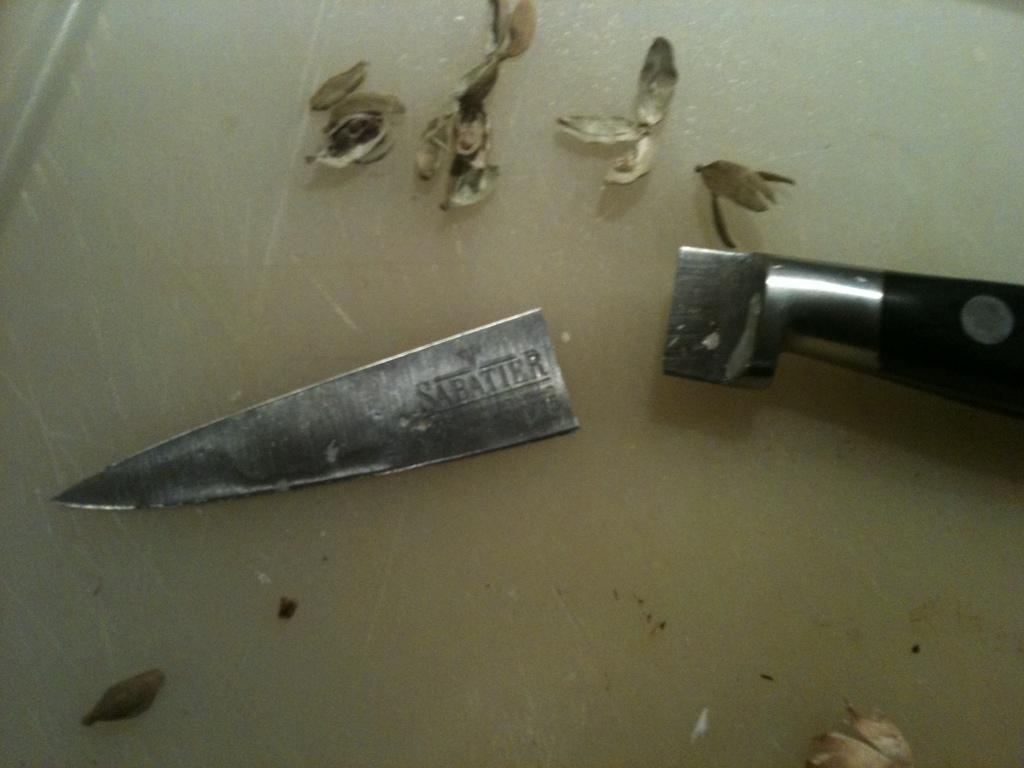What object appears to be damaged in the image? There is a broken knife in the image. What type of spice can be seen in the image? There are cardamoms in the image. Where is the basketball located in the image? There is no basketball present in the image. What type of weather is depicted in the image? The image does not depict any weather or snow; it only shows a broken knife and cardamoms. 